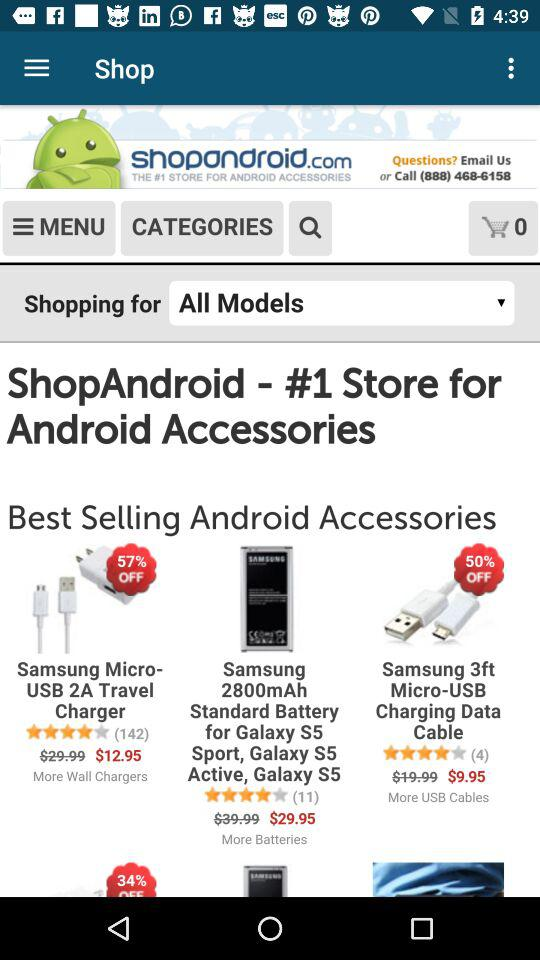What is the original price of "Samsung 3ft Micro-USB"? The original price of the "Samsung 3ft Micro-USB" is $19.99. 